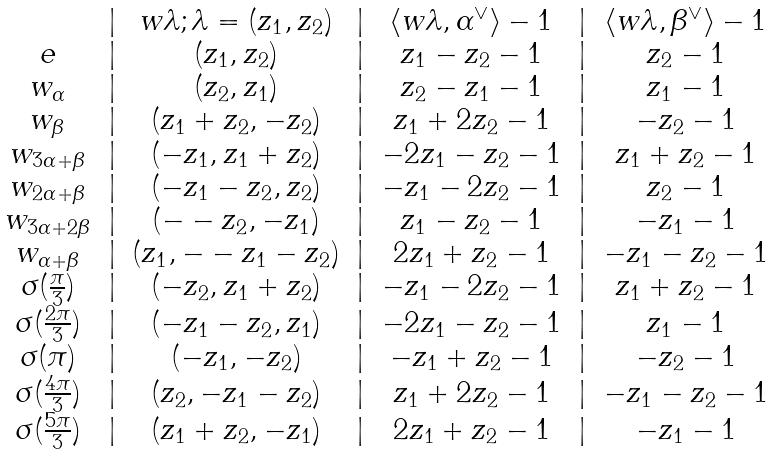Convert formula to latex. <formula><loc_0><loc_0><loc_500><loc_500>\begin{matrix} & | & w \lambda ; \lambda = ( z _ { 1 } , z _ { 2 } ) & | & \langle w \lambda , \alpha ^ { \vee } \rangle - 1 & | & \langle w \lambda , \beta ^ { \vee } \rangle - 1 \\ e & | & ( z _ { 1 } , z _ { 2 } ) & | & z _ { 1 } - z _ { 2 } - 1 & | & z _ { 2 } - 1 \\ w _ { \alpha } & | & ( z _ { 2 } , z _ { 1 } ) & | & z _ { 2 } - z _ { 1 } - 1 & | & z _ { 1 } - 1 \\ w _ { \beta } & | & ( z _ { 1 } + z _ { 2 } , - z _ { 2 } ) & | & z _ { 1 } + 2 z _ { 2 } - 1 & | & - z _ { 2 } - 1 \\ w _ { 3 \alpha + \beta } & | & ( - z _ { 1 } , z _ { 1 } + z _ { 2 } ) & | & - 2 z _ { 1 } - z _ { 2 } - 1 & | & z _ { 1 } + z _ { 2 } - 1 \\ w _ { 2 \alpha + \beta } & | & ( - z _ { 1 } - z _ { 2 } , z _ { 2 } ) & | & - z _ { 1 } - 2 z _ { 2 } - 1 & | & z _ { 2 } - 1 \\ w _ { 3 \alpha + 2 \beta } & | & ( - - z _ { 2 } , - z _ { 1 } ) & | & z _ { 1 } - z _ { 2 } - 1 & | & - z _ { 1 } - 1 \\ w _ { \alpha + \beta } & | & ( z _ { 1 } , - - z _ { 1 } - z _ { 2 } ) & | & 2 z _ { 1 } + z _ { 2 } - 1 & | & - z _ { 1 } - z _ { 2 } - 1 \\ \sigma ( \frac { \pi } { 3 } ) & | & ( - z _ { 2 } , z _ { 1 } + z _ { 2 } ) & | & - z _ { 1 } - 2 z _ { 2 } - 1 & | & z _ { 1 } + z _ { 2 } - 1 \\ \sigma ( \frac { 2 \pi } { 3 } ) & | & ( - z _ { 1 } - z _ { 2 } , z _ { 1 } ) & | & - 2 z _ { 1 } - z _ { 2 } - 1 & | & z _ { 1 } - 1 \\ \sigma ( \pi ) & | & ( - z _ { 1 } , - z _ { 2 } ) & | & - z _ { 1 } + z _ { 2 } - 1 & | & - z _ { 2 } - 1 \\ \sigma ( \frac { 4 \pi } { 3 } ) & | & ( z _ { 2 } , - z _ { 1 } - z _ { 2 } ) & | & z _ { 1 } + 2 z _ { 2 } - 1 & | & - z _ { 1 } - z _ { 2 } - 1 \\ \sigma ( \frac { 5 \pi } { 3 } ) & | & ( z _ { 1 } + z _ { 2 } , - z _ { 1 } ) & | & 2 z _ { 1 } + z _ { 2 } - 1 & | & - z _ { 1 } - 1 \end{matrix}</formula> 